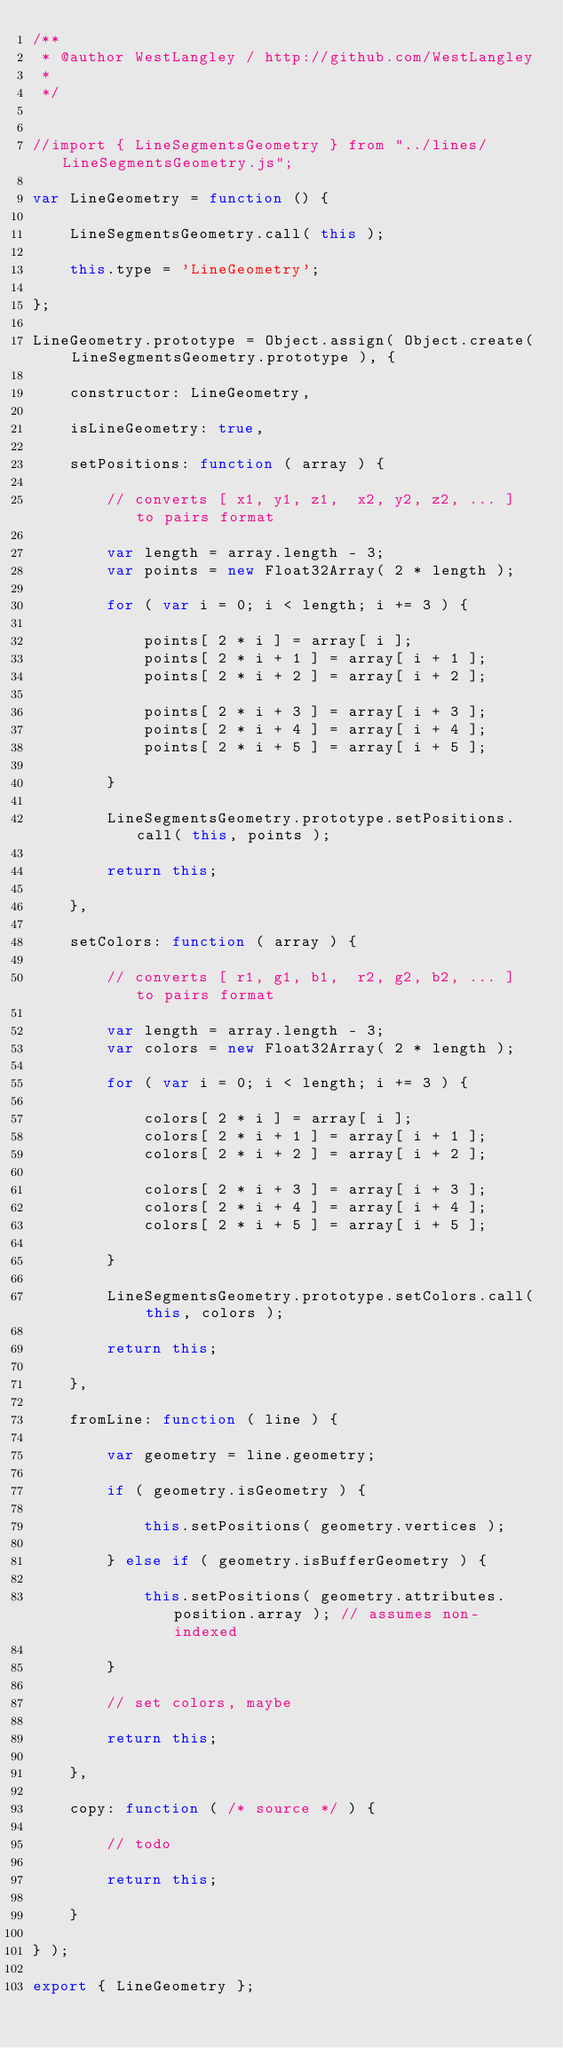Convert code to text. <code><loc_0><loc_0><loc_500><loc_500><_JavaScript_>/**
 * @author WestLangley / http://github.com/WestLangley
 *
 */


//import { LineSegmentsGeometry } from "../lines/LineSegmentsGeometry.js";

var LineGeometry = function () {

	LineSegmentsGeometry.call( this );

	this.type = 'LineGeometry';

};

LineGeometry.prototype = Object.assign( Object.create( LineSegmentsGeometry.prototype ), {

	constructor: LineGeometry,

	isLineGeometry: true,

	setPositions: function ( array ) {

		// converts [ x1, y1, z1,  x2, y2, z2, ... ] to pairs format

		var length = array.length - 3;
		var points = new Float32Array( 2 * length );

		for ( var i = 0; i < length; i += 3 ) {

			points[ 2 * i ] = array[ i ];
			points[ 2 * i + 1 ] = array[ i + 1 ];
			points[ 2 * i + 2 ] = array[ i + 2 ];

			points[ 2 * i + 3 ] = array[ i + 3 ];
			points[ 2 * i + 4 ] = array[ i + 4 ];
			points[ 2 * i + 5 ] = array[ i + 5 ];

		}

		LineSegmentsGeometry.prototype.setPositions.call( this, points );

		return this;

	},

	setColors: function ( array ) {

		// converts [ r1, g1, b1,  r2, g2, b2, ... ] to pairs format

		var length = array.length - 3;
		var colors = new Float32Array( 2 * length );

		for ( var i = 0; i < length; i += 3 ) {

			colors[ 2 * i ] = array[ i ];
			colors[ 2 * i + 1 ] = array[ i + 1 ];
			colors[ 2 * i + 2 ] = array[ i + 2 ];

			colors[ 2 * i + 3 ] = array[ i + 3 ];
			colors[ 2 * i + 4 ] = array[ i + 4 ];
			colors[ 2 * i + 5 ] = array[ i + 5 ];

		}

		LineSegmentsGeometry.prototype.setColors.call( this, colors );

		return this;

	},

	fromLine: function ( line ) {

		var geometry = line.geometry;

		if ( geometry.isGeometry ) {

			this.setPositions( geometry.vertices );

		} else if ( geometry.isBufferGeometry ) {

			this.setPositions( geometry.attributes.position.array ); // assumes non-indexed

		}

		// set colors, maybe

		return this;

	},

	copy: function ( /* source */ ) {

		// todo

		return this;

	}

} );

export { LineGeometry };
</code> 